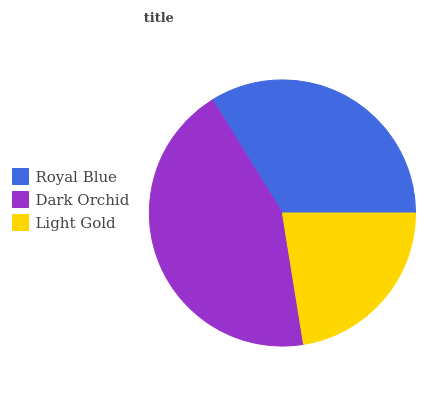Is Light Gold the minimum?
Answer yes or no. Yes. Is Dark Orchid the maximum?
Answer yes or no. Yes. Is Dark Orchid the minimum?
Answer yes or no. No. Is Light Gold the maximum?
Answer yes or no. No. Is Dark Orchid greater than Light Gold?
Answer yes or no. Yes. Is Light Gold less than Dark Orchid?
Answer yes or no. Yes. Is Light Gold greater than Dark Orchid?
Answer yes or no. No. Is Dark Orchid less than Light Gold?
Answer yes or no. No. Is Royal Blue the high median?
Answer yes or no. Yes. Is Royal Blue the low median?
Answer yes or no. Yes. Is Light Gold the high median?
Answer yes or no. No. Is Light Gold the low median?
Answer yes or no. No. 